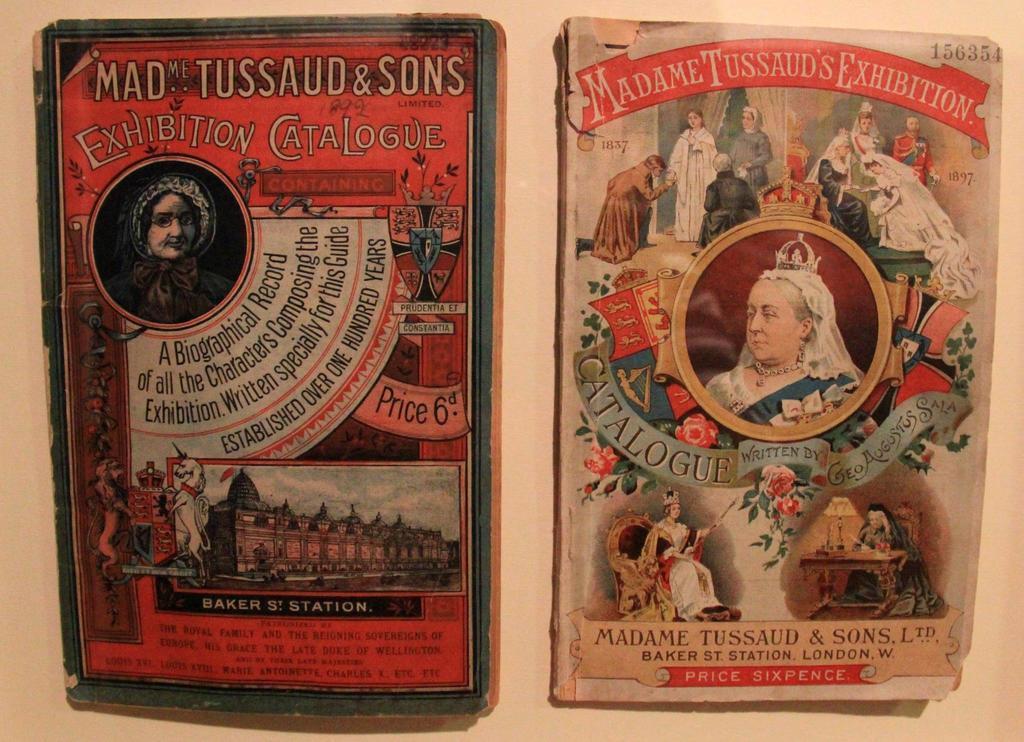In one or two sentences, can you explain what this image depicts? In the image we can see these are the book covers and on the cover we can see the picture of a person, this is a flower, building, shield and horse 